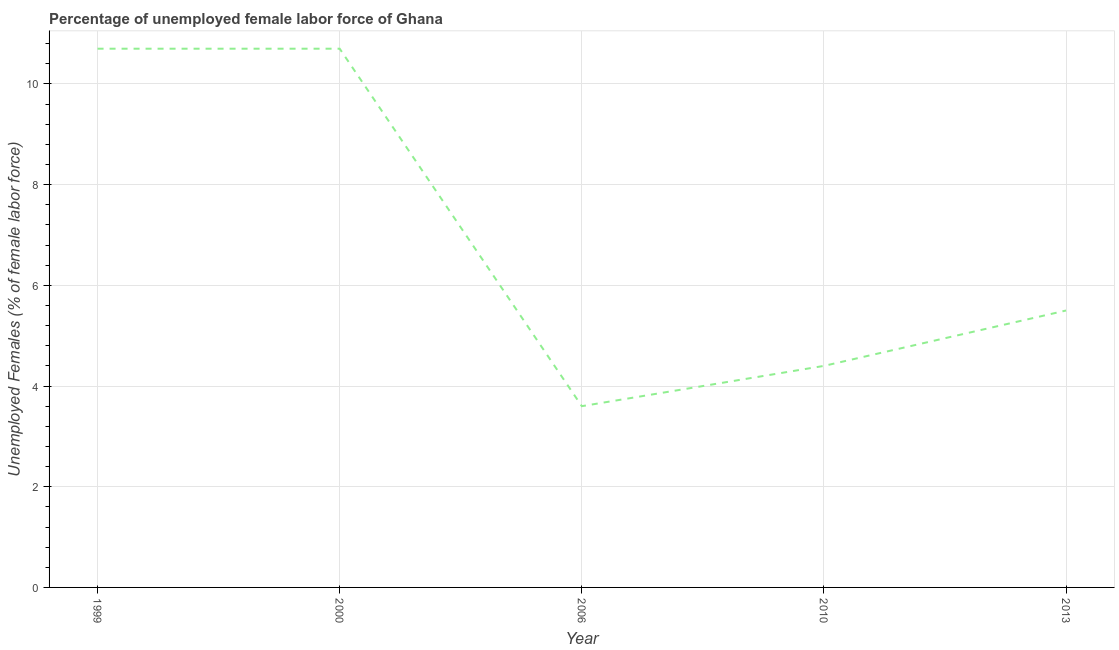What is the total unemployed female labour force in 2010?
Your answer should be very brief. 4.4. Across all years, what is the maximum total unemployed female labour force?
Offer a terse response. 10.7. Across all years, what is the minimum total unemployed female labour force?
Keep it short and to the point. 3.6. What is the sum of the total unemployed female labour force?
Your answer should be compact. 34.9. What is the difference between the total unemployed female labour force in 1999 and 2006?
Your response must be concise. 7.1. What is the average total unemployed female labour force per year?
Give a very brief answer. 6.98. In how many years, is the total unemployed female labour force greater than 4.4 %?
Ensure brevity in your answer.  4. What is the ratio of the total unemployed female labour force in 2010 to that in 2013?
Provide a short and direct response. 0.8. Is the total unemployed female labour force in 1999 less than that in 2013?
Offer a very short reply. No. Is the sum of the total unemployed female labour force in 2006 and 2013 greater than the maximum total unemployed female labour force across all years?
Your answer should be very brief. No. What is the difference between the highest and the lowest total unemployed female labour force?
Your response must be concise. 7.1. In how many years, is the total unemployed female labour force greater than the average total unemployed female labour force taken over all years?
Make the answer very short. 2. Does the total unemployed female labour force monotonically increase over the years?
Your answer should be very brief. No. How many lines are there?
Keep it short and to the point. 1. What is the difference between two consecutive major ticks on the Y-axis?
Provide a succinct answer. 2. Are the values on the major ticks of Y-axis written in scientific E-notation?
Your answer should be compact. No. Does the graph contain any zero values?
Provide a succinct answer. No. Does the graph contain grids?
Ensure brevity in your answer.  Yes. What is the title of the graph?
Your response must be concise. Percentage of unemployed female labor force of Ghana. What is the label or title of the X-axis?
Your response must be concise. Year. What is the label or title of the Y-axis?
Keep it short and to the point. Unemployed Females (% of female labor force). What is the Unemployed Females (% of female labor force) in 1999?
Offer a very short reply. 10.7. What is the Unemployed Females (% of female labor force) in 2000?
Your answer should be compact. 10.7. What is the Unemployed Females (% of female labor force) in 2006?
Make the answer very short. 3.6. What is the Unemployed Females (% of female labor force) of 2010?
Ensure brevity in your answer.  4.4. What is the difference between the Unemployed Females (% of female labor force) in 1999 and 2000?
Provide a succinct answer. 0. What is the difference between the Unemployed Females (% of female labor force) in 1999 and 2010?
Your answer should be very brief. 6.3. What is the difference between the Unemployed Females (% of female labor force) in 1999 and 2013?
Offer a very short reply. 5.2. What is the difference between the Unemployed Females (% of female labor force) in 2000 and 2006?
Offer a very short reply. 7.1. What is the difference between the Unemployed Females (% of female labor force) in 2000 and 2010?
Provide a succinct answer. 6.3. What is the difference between the Unemployed Females (% of female labor force) in 2000 and 2013?
Provide a succinct answer. 5.2. What is the difference between the Unemployed Females (% of female labor force) in 2010 and 2013?
Offer a very short reply. -1.1. What is the ratio of the Unemployed Females (% of female labor force) in 1999 to that in 2006?
Your answer should be very brief. 2.97. What is the ratio of the Unemployed Females (% of female labor force) in 1999 to that in 2010?
Keep it short and to the point. 2.43. What is the ratio of the Unemployed Females (% of female labor force) in 1999 to that in 2013?
Your answer should be very brief. 1.95. What is the ratio of the Unemployed Females (% of female labor force) in 2000 to that in 2006?
Your answer should be compact. 2.97. What is the ratio of the Unemployed Females (% of female labor force) in 2000 to that in 2010?
Your answer should be compact. 2.43. What is the ratio of the Unemployed Females (% of female labor force) in 2000 to that in 2013?
Your answer should be very brief. 1.95. What is the ratio of the Unemployed Females (% of female labor force) in 2006 to that in 2010?
Make the answer very short. 0.82. What is the ratio of the Unemployed Females (% of female labor force) in 2006 to that in 2013?
Offer a very short reply. 0.66. 